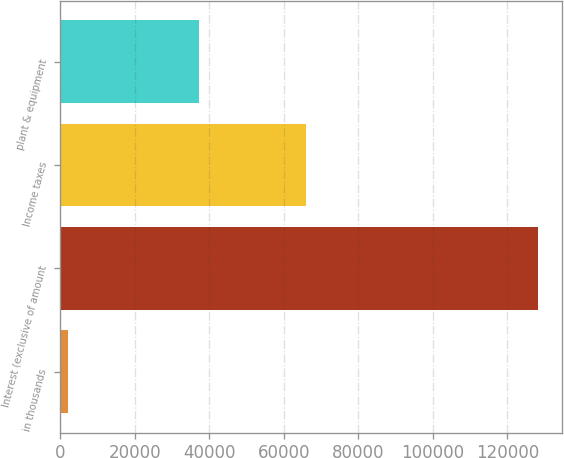Convert chart to OTSL. <chart><loc_0><loc_0><loc_500><loc_500><bar_chart><fcel>in thousands<fcel>Interest (exclusive of amount<fcel>Income taxes<fcel>plant & equipment<nl><fcel>2018<fcel>128217<fcel>65968<fcel>37116<nl></chart> 